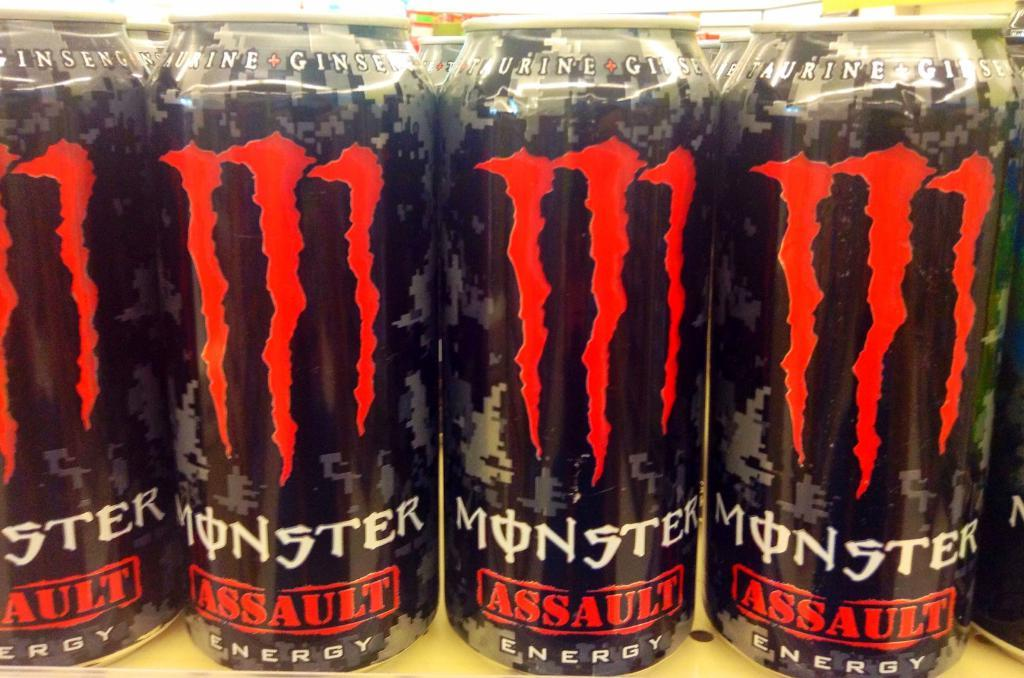<image>
Write a terse but informative summary of the picture. some MOnster drinks that are red and black 